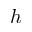Convert formula to latex. <formula><loc_0><loc_0><loc_500><loc_500>h</formula> 